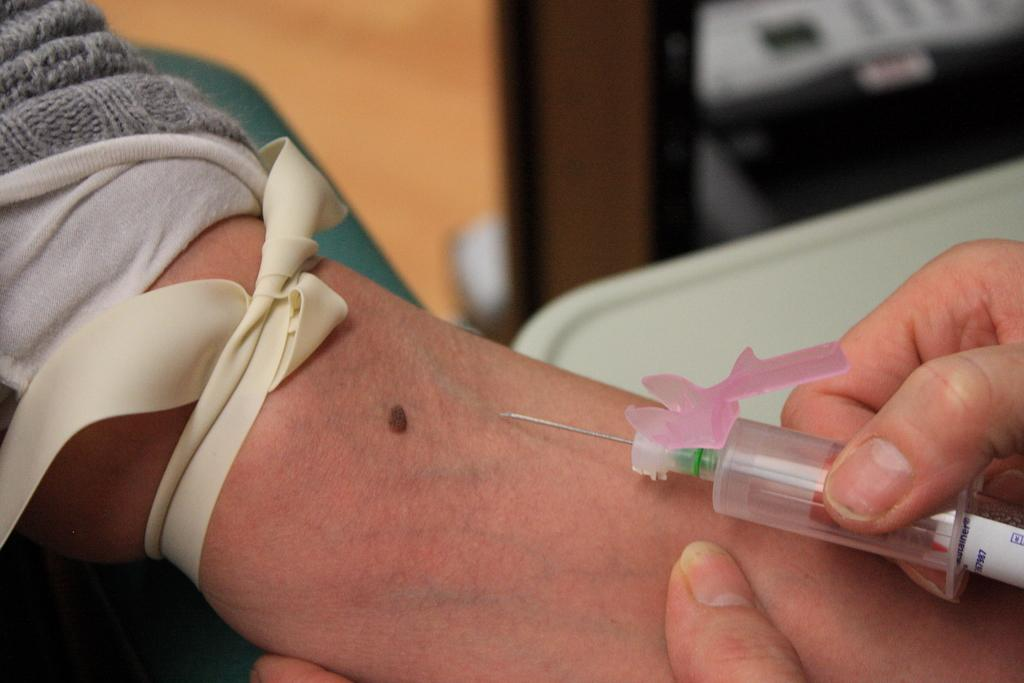What is the person holding in the image? The person is holding a syringe in the image. What is attached to the person's hand? The person's hand has a ribbon tied to it. Can you describe the background of the image? There are objects visible in the background of the image. What type of sky can be seen in the image? There is no mention of a sky in the image. 